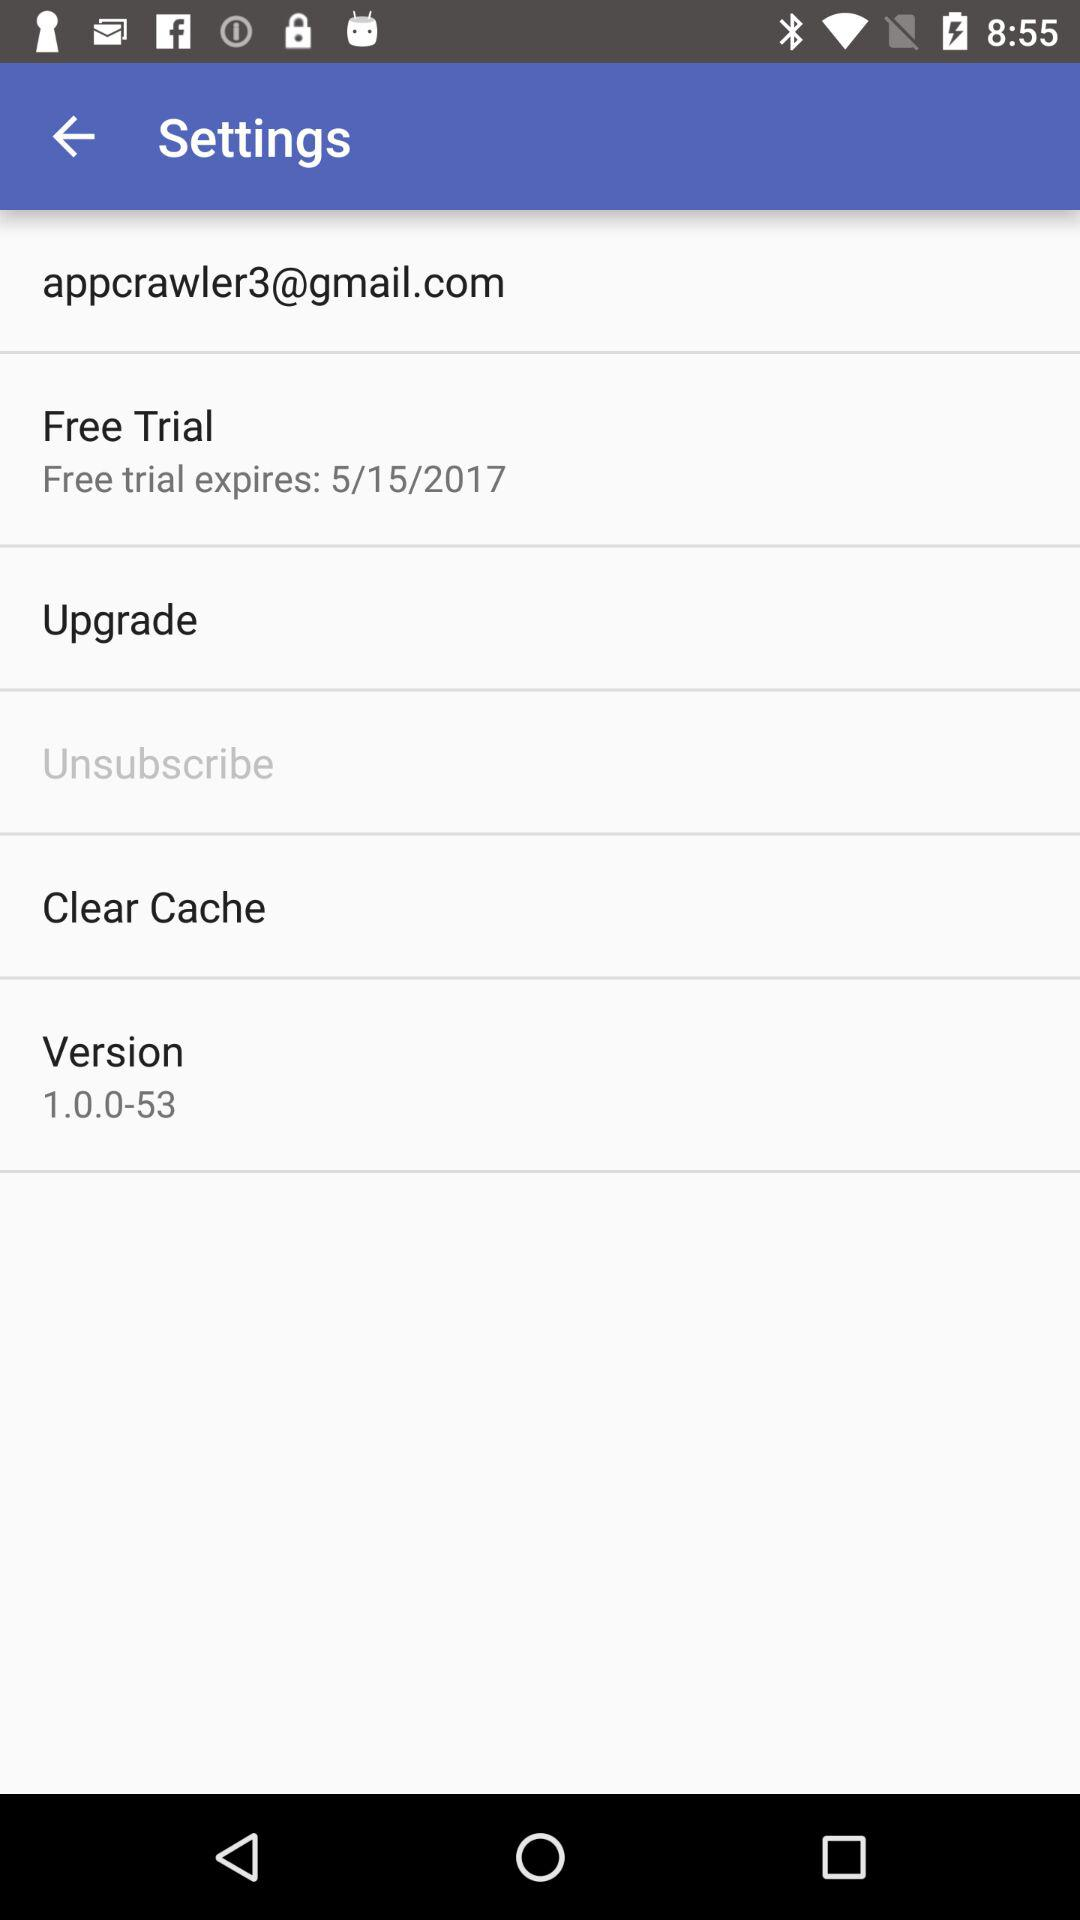What is the email address? The email address is appcrawler3@gmail.com. 